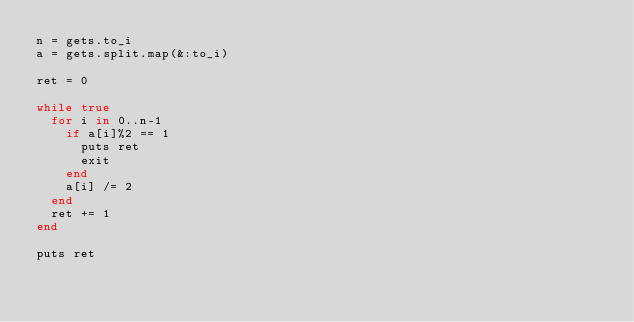Convert code to text. <code><loc_0><loc_0><loc_500><loc_500><_Ruby_>n = gets.to_i
a = gets.split.map(&:to_i)

ret = 0

while true
  for i in 0..n-1
    if a[i]%2 == 1
      puts ret
      exit
    end
    a[i] /= 2
  end
  ret += 1
end

puts ret
</code> 